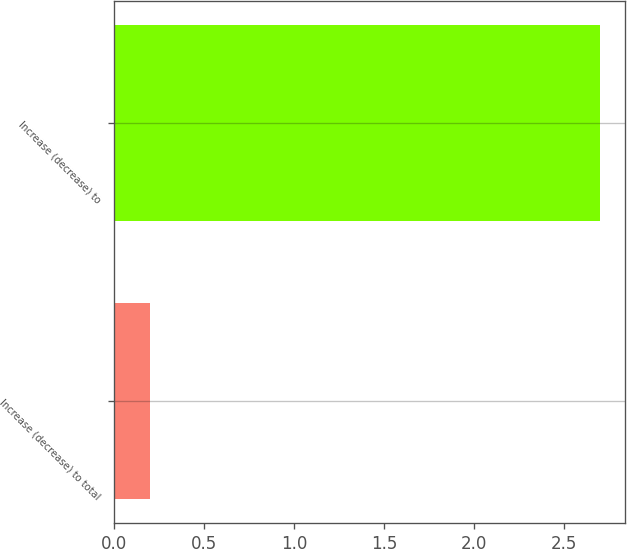<chart> <loc_0><loc_0><loc_500><loc_500><bar_chart><fcel>Increase (decrease) to total<fcel>Increase (decrease) to<nl><fcel>0.2<fcel>2.7<nl></chart> 